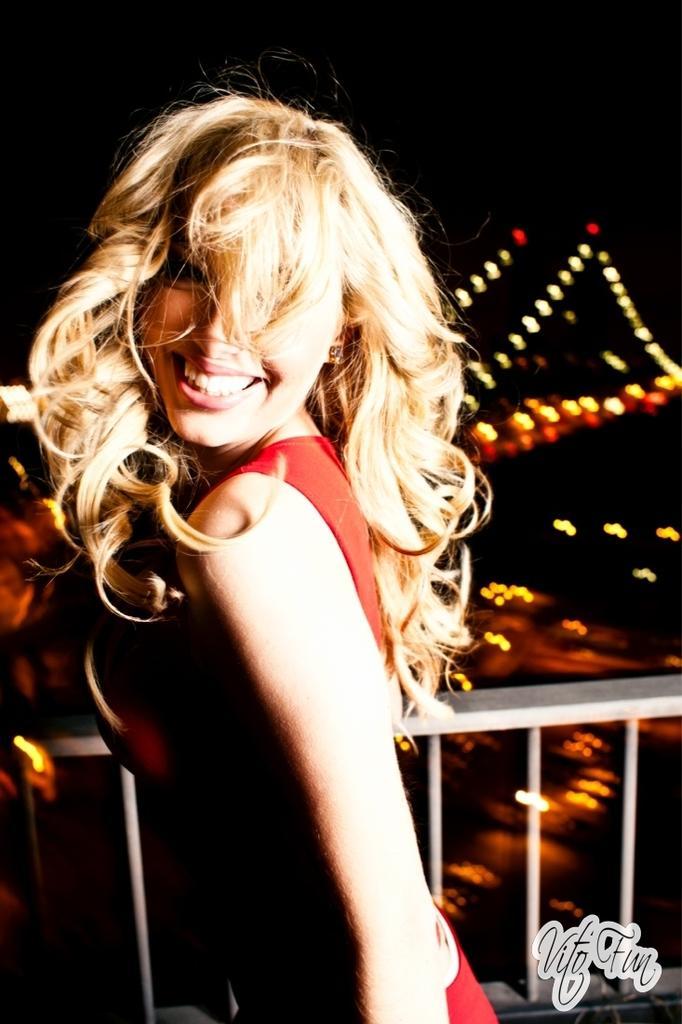How would you summarize this image in a sentence or two? In this image I can see the person standing and wearing the red color dress and she is smiling. She is standing to the side of the railing. In the back I can see the many lights and there is a black background. 